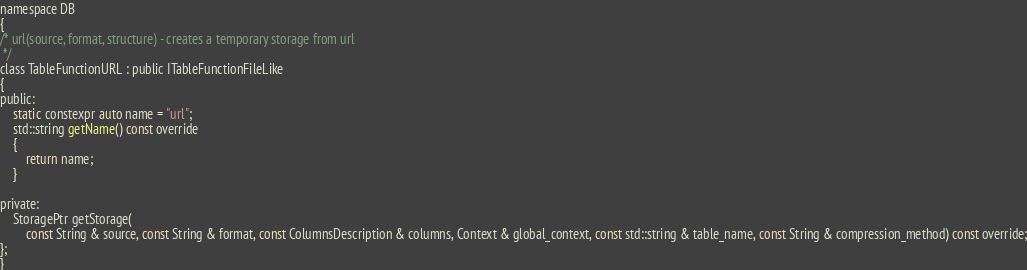Convert code to text. <code><loc_0><loc_0><loc_500><loc_500><_C_>

namespace DB
{
/* url(source, format, structure) - creates a temporary storage from url
 */
class TableFunctionURL : public ITableFunctionFileLike
{
public:
    static constexpr auto name = "url";
    std::string getName() const override
    {
        return name;
    }

private:
    StoragePtr getStorage(
        const String & source, const String & format, const ColumnsDescription & columns, Context & global_context, const std::string & table_name, const String & compression_method) const override;
};
}
</code> 